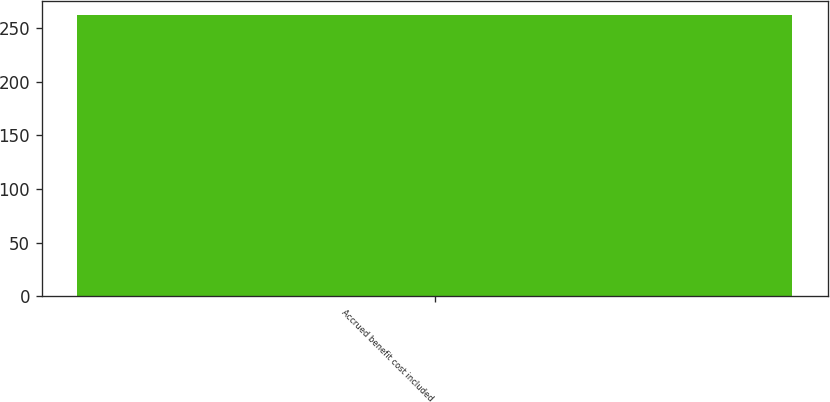Convert chart. <chart><loc_0><loc_0><loc_500><loc_500><bar_chart><fcel>Accrued benefit cost included<nl><fcel>262<nl></chart> 